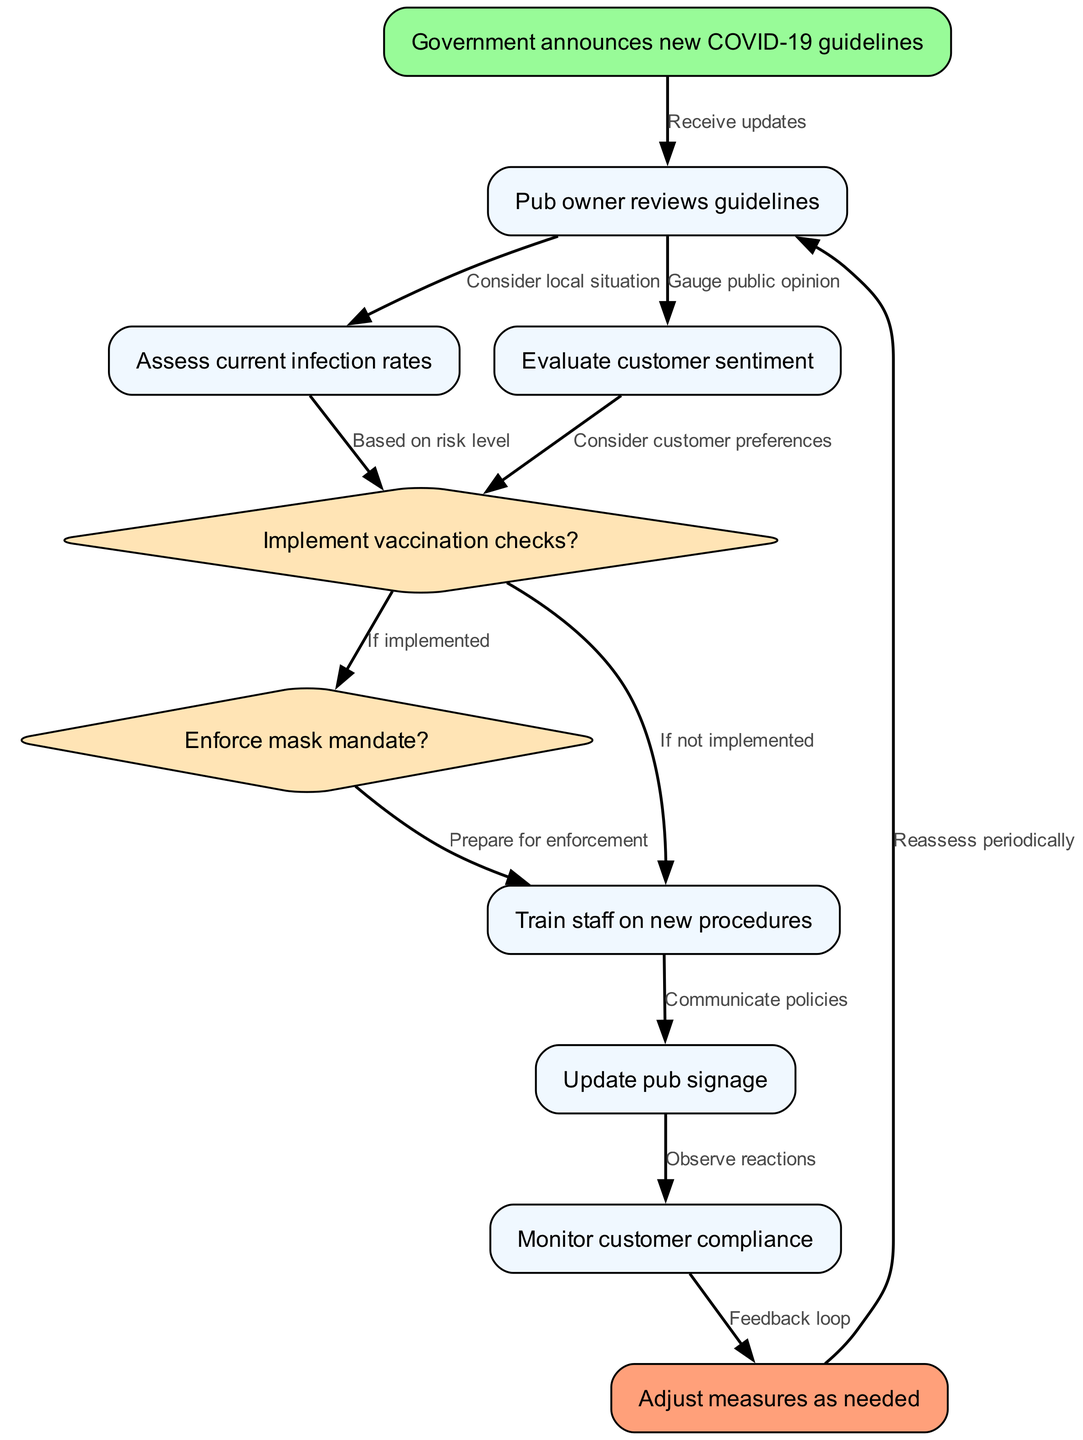What is the first step in the decision-making process? The first step is when the Government announces new COVID-19 guidelines, which is represented as node 1 in the diagram.
Answer: Government announces new COVID-19 guidelines How many decision nodes are present in the flowchart? There are two decision nodes in the flowchart, which are nodes 5 (Implement vaccination checks?) and 6 (Enforce mask mandate?).
Answer: 2 What happens after the pub owner reviews the guidelines? After reviewing the guidelines, the pub owner assesses current infection rates (node 3) and evaluates customer sentiment (node 4), which directly follow node 2 in the diagram.
Answer: Assess current infection rates and Evaluate customer sentiment If vaccination checks are implemented, what is the next step? If vaccination checks are implemented (indicated by node 5), the next step to take is to enforce the mask mandate (node 6). This is depicted as an edge from node 5 to node 6 in the diagram.
Answer: Enforce mask mandate? How does customer compliance get monitored? Customer compliance is monitored after updating the pub signage (node 8) and observing reactions (node 9), which directly follows the update in signage. This means monitoring compliance is the next logical step in the process after these actions.
Answer: Monitor customer compliance What type of feedback loop exists in the process? There is a feedback loop indicated between node 9 (Monitor customer compliance) and node 10 (Adjust measures as needed), which leads back to node 2 for periodic reassessment of the guidelines.
Answer: Feedback loop What role does staff training play in the process? Staff training occurs after deciding whether to implement vaccination checks or not, ensuring they are prepared for enforcing the new measures. This is an essential step represented by node 7 in the flowchart.
Answer: Train staff on new procedures What should happen periodically according to the diagram? Periodically, the steps should involve reassessing the situation which involves going back to node 2 after adjusting measures as needed (node 10). This emphasizes the importance of continuous evaluation in the decision-making process.
Answer: Reassess periodically 